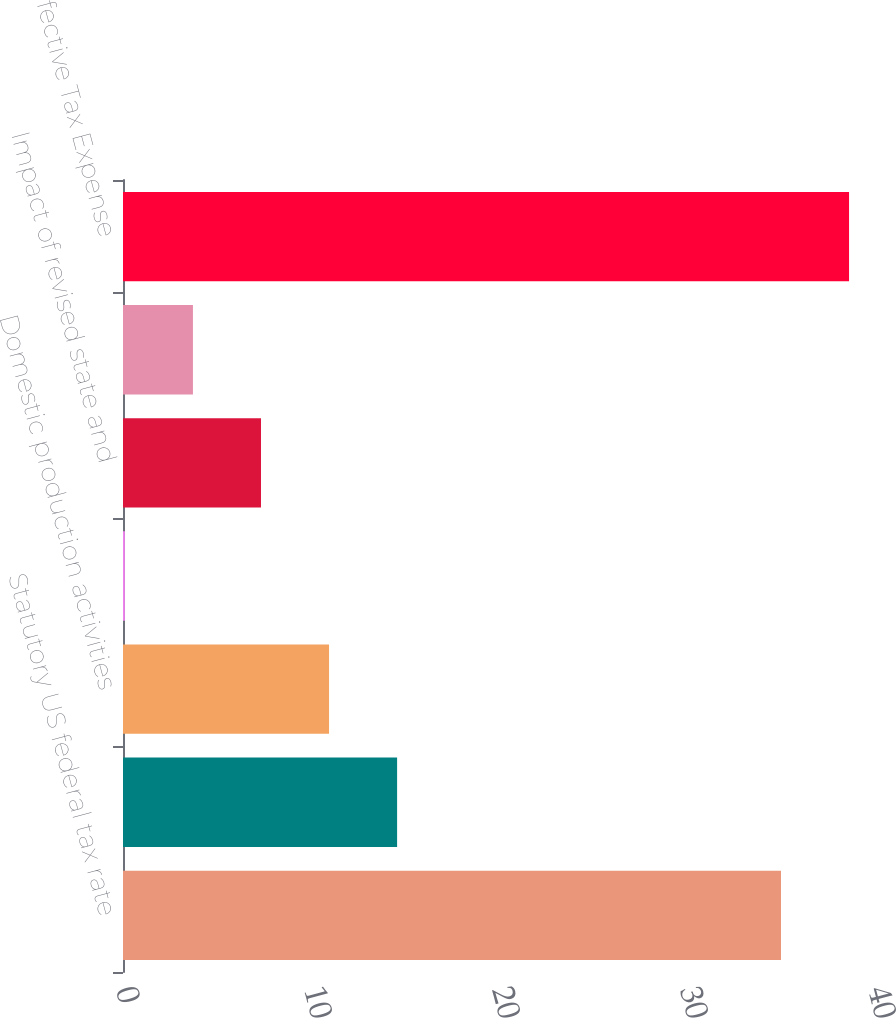<chart> <loc_0><loc_0><loc_500><loc_500><bar_chart><fcel>Statutory US federal tax rate<fcel>State taxes net of federal<fcel>Domestic production activities<fcel>Increase (decrease) in<fcel>Impact of revised state and<fcel>Other net<fcel>Effective Tax Expense<nl><fcel>35<fcel>14.58<fcel>10.96<fcel>0.1<fcel>7.34<fcel>3.72<fcel>38.62<nl></chart> 